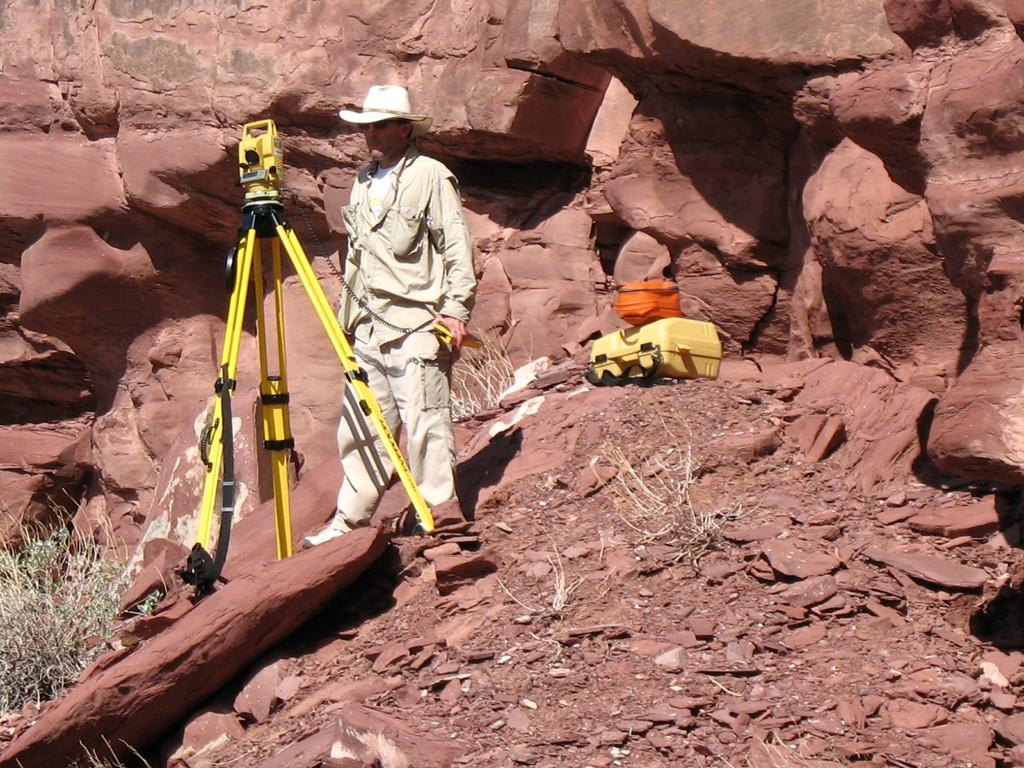What is the main subject of the image? There is a man standing in the image. What is in front of the man? There is a stand in front of the man. What type of natural elements can be seen in the image? There are rocks visible at the back of the image. What type of room is the man standing in? The image does not provide information about the room, as it only shows the man, the stand, and the rocks. 